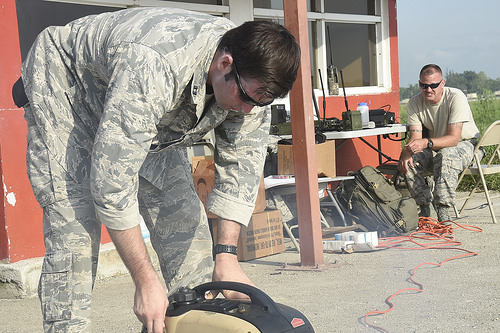<image>
Is the man behind the building? No. The man is not behind the building. From this viewpoint, the man appears to be positioned elsewhere in the scene. 